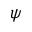<formula> <loc_0><loc_0><loc_500><loc_500>\psi</formula> 